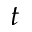Convert formula to latex. <formula><loc_0><loc_0><loc_500><loc_500>t</formula> 